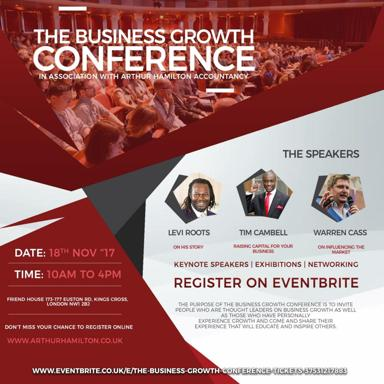What is the purpose of The Business Growth Conference? The Business Growth Conference is designed to connect business leaders and movers, creating a dynamic environment for exchanging ideas and strategies. It focuses on inspiring leadership, cutting-edge marketing strategies, and fostering a network of growth-minded professionals. What additional features does the conference offer? Apart from keynote speeches, the conference features a variety of exhibitions where businesses can showcase their products and services. There are also numerous networking sessions scheduled throughout the day, aimed at building lasting professional relationships. 